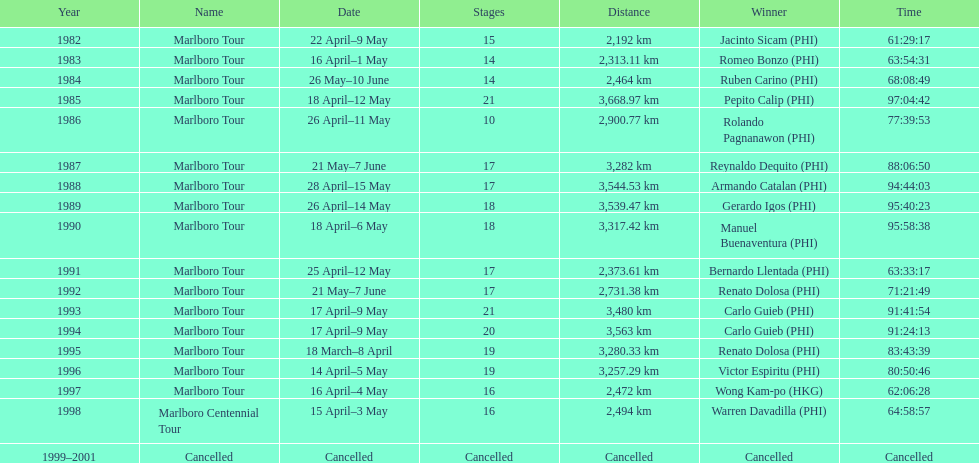How many marlboro tours did carlo guieb win? 2. 